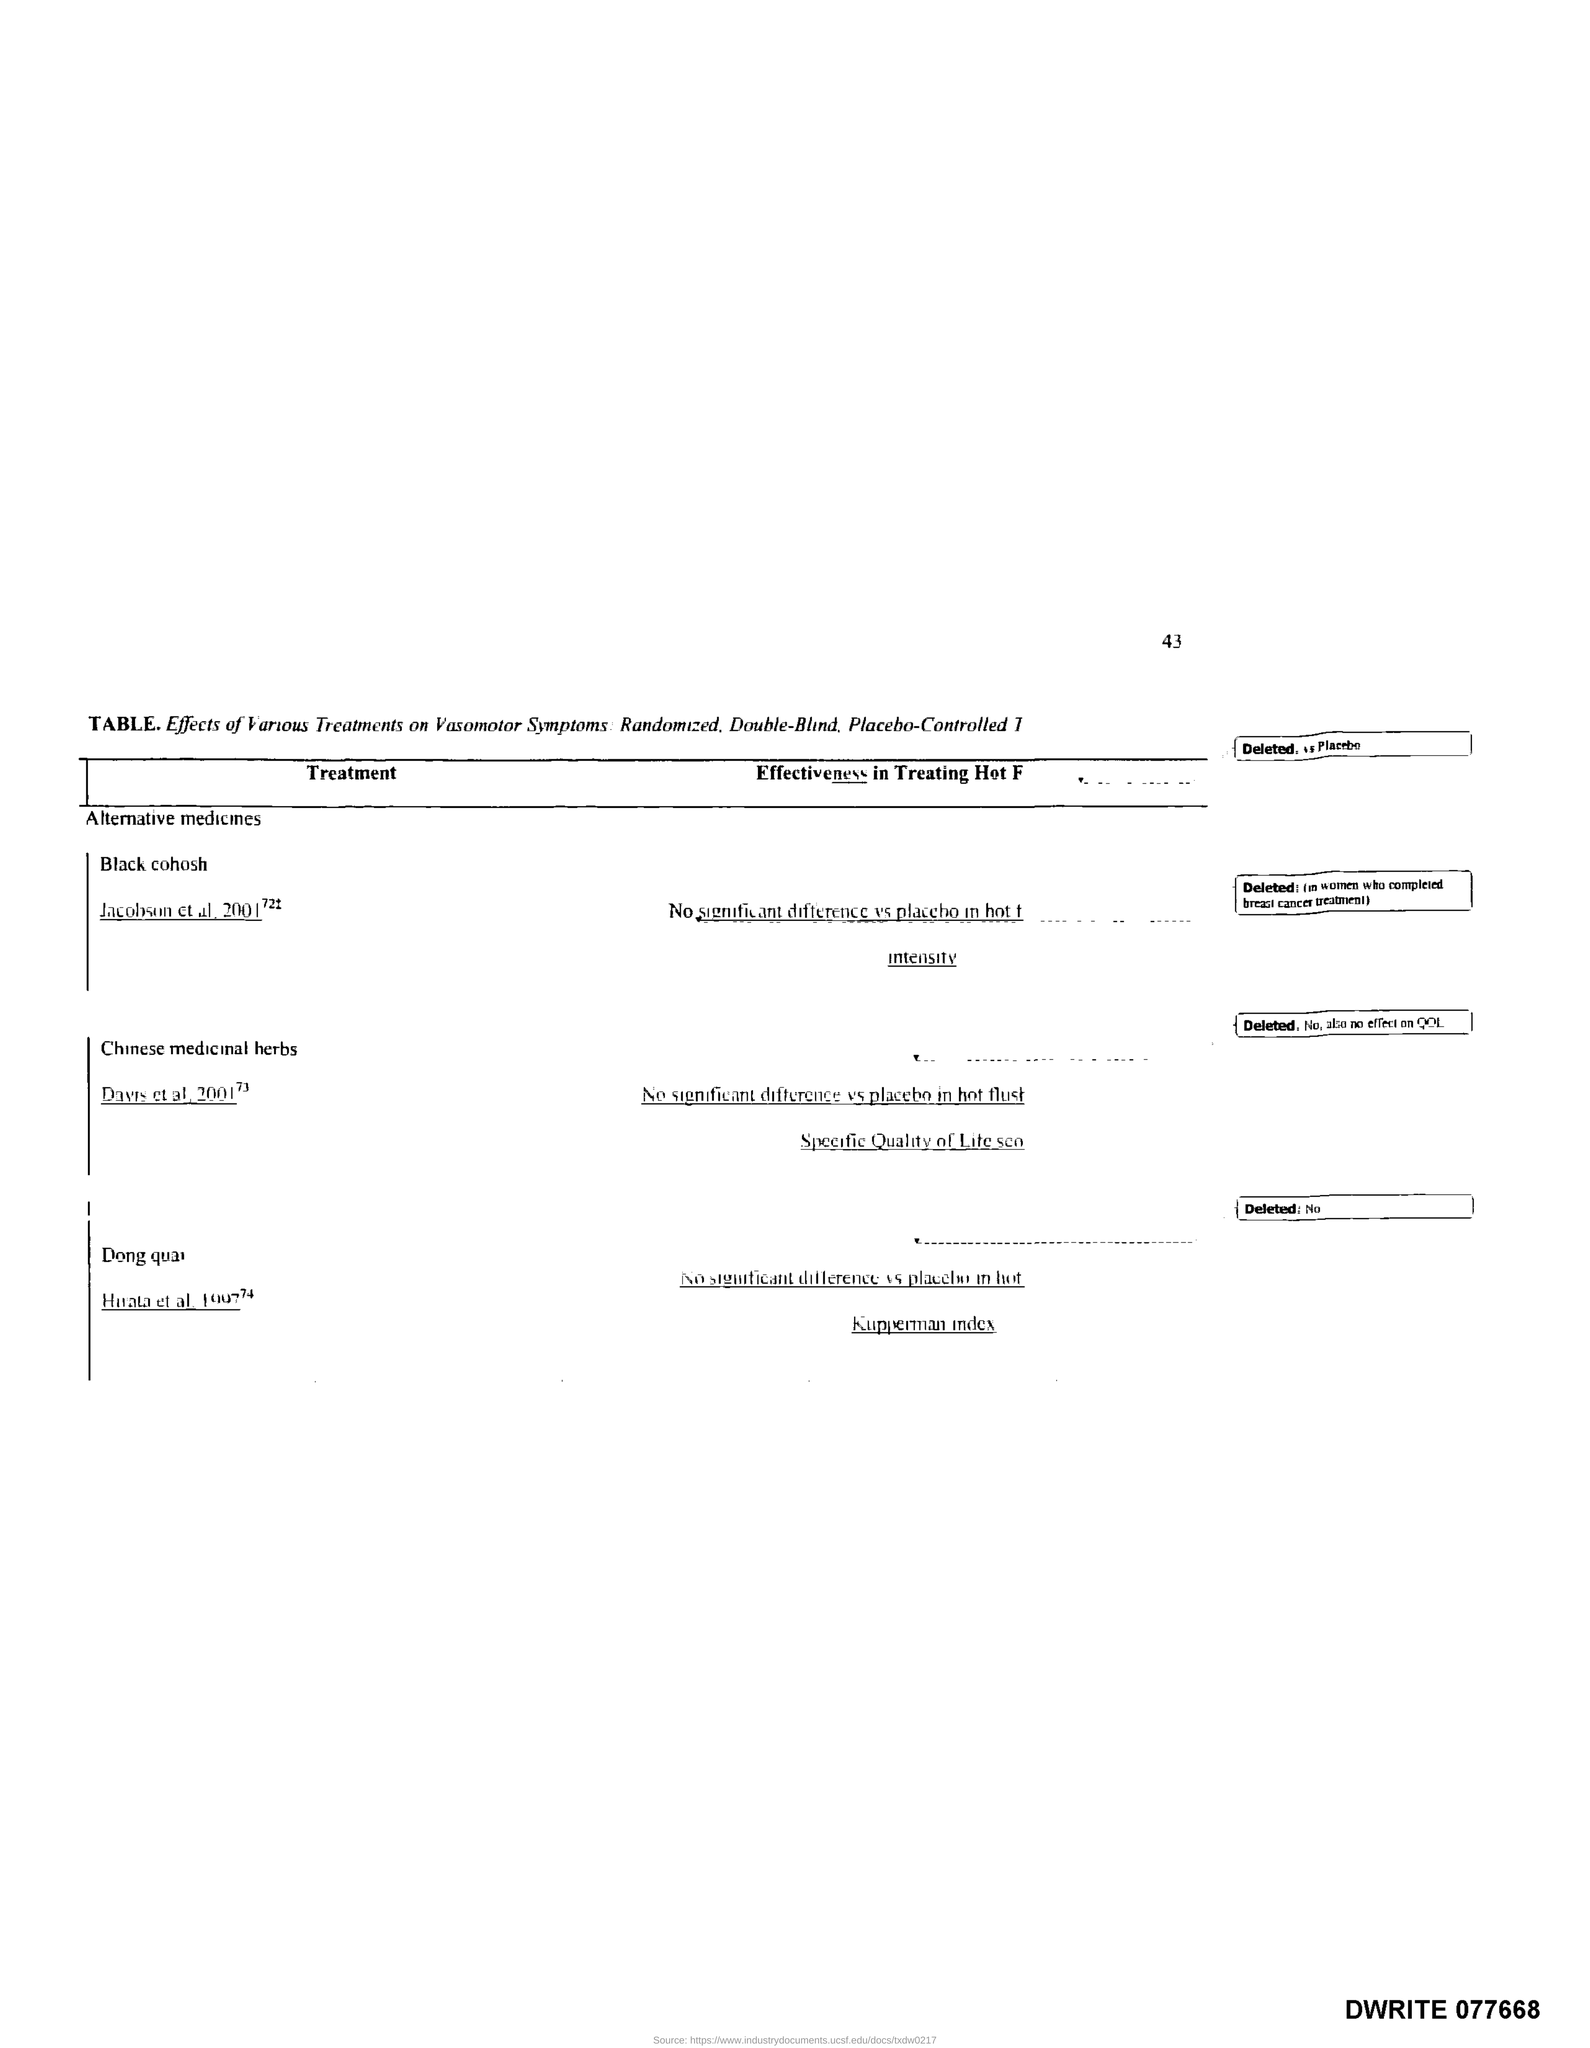What is the page number?
Provide a short and direct response. 43. What is the title of the first column of the table?
Offer a terse response. Treatment. 